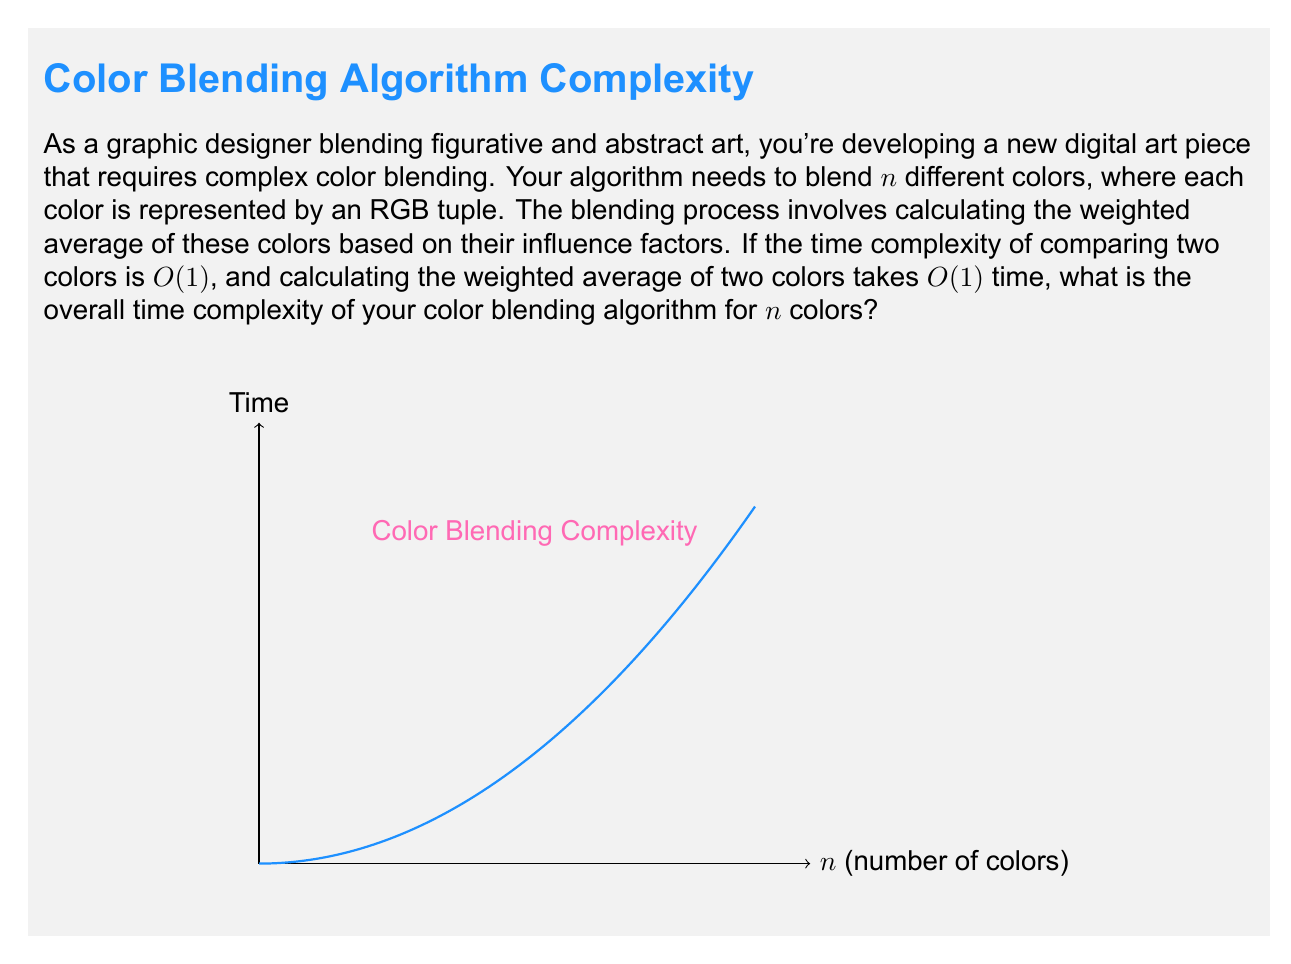Teach me how to tackle this problem. Let's approach this step-by-step:

1) First, we need to understand what operations are involved in blending $n$ colors:
   - We need to compare each color with every other color to determine their relationships.
   - We need to calculate the weighted average of all colors.

2) For comparing colors:
   - We need to compare each color with every other color.
   - This is similar to choosing 2 colors from n colors, which gives us $\binom{n}{2} = \frac{n(n-1)}{2}$ comparisons.
   - Each comparison takes $O(1)$ time.
   - So, the total time for comparisons is $O(n^2)$.

3) For calculating the weighted average:
   - We need to include each color in our calculation.
   - This means we perform $n-1$ weighted average calculations.
   - Each calculation takes $O(1)$ time.
   - So, the total time for weighted average calculation is $O(n)$.

4) The total time complexity is the sum of these two operations:
   $O(n^2) + O(n) = O(n^2)$

5) In Big O notation, we only keep the term with the highest order, so our final complexity is $O(n^2)$.

This quadratic time complexity is represented by the parabolic curve in the graph, showing how the time increases as the number of colors increases.
Answer: $O(n^2)$ 